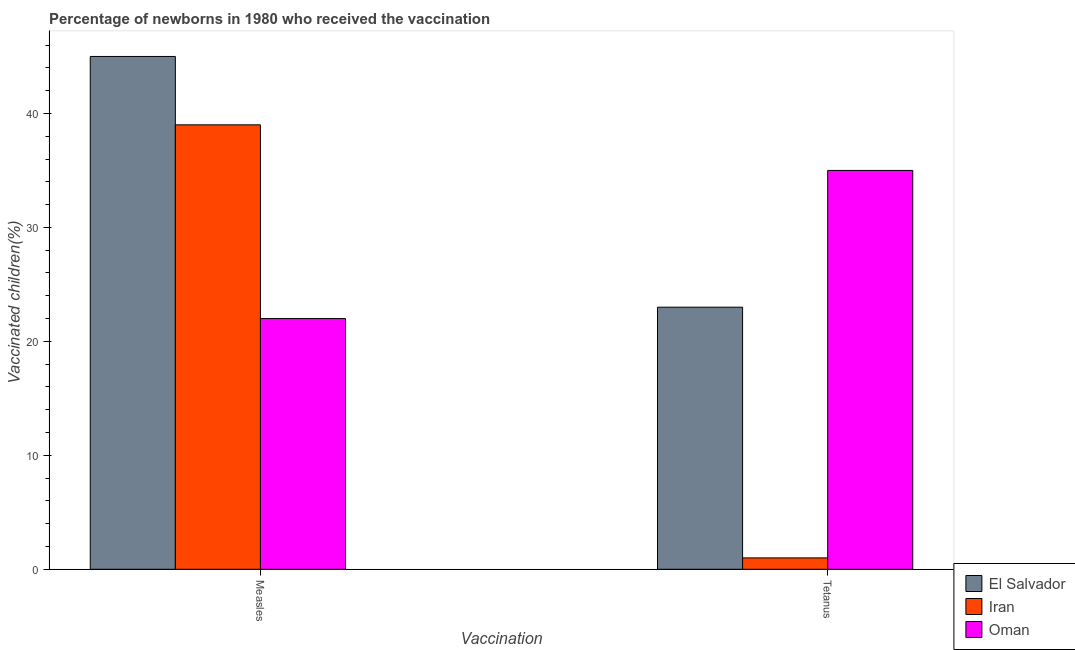How many different coloured bars are there?
Offer a very short reply. 3. How many groups of bars are there?
Your answer should be compact. 2. Are the number of bars per tick equal to the number of legend labels?
Keep it short and to the point. Yes. Are the number of bars on each tick of the X-axis equal?
Your answer should be compact. Yes. How many bars are there on the 2nd tick from the right?
Your answer should be compact. 3. What is the label of the 2nd group of bars from the left?
Provide a short and direct response. Tetanus. What is the percentage of newborns who received vaccination for measles in El Salvador?
Ensure brevity in your answer.  45. Across all countries, what is the maximum percentage of newborns who received vaccination for measles?
Make the answer very short. 45. Across all countries, what is the minimum percentage of newborns who received vaccination for measles?
Provide a succinct answer. 22. In which country was the percentage of newborns who received vaccination for measles maximum?
Your response must be concise. El Salvador. In which country was the percentage of newborns who received vaccination for tetanus minimum?
Keep it short and to the point. Iran. What is the total percentage of newborns who received vaccination for measles in the graph?
Give a very brief answer. 106. What is the difference between the percentage of newborns who received vaccination for tetanus in Iran and that in Oman?
Offer a terse response. -34. What is the difference between the percentage of newborns who received vaccination for measles in El Salvador and the percentage of newborns who received vaccination for tetanus in Iran?
Offer a very short reply. 44. What is the average percentage of newborns who received vaccination for measles per country?
Offer a terse response. 35.33. What is the difference between the percentage of newborns who received vaccination for measles and percentage of newborns who received vaccination for tetanus in Iran?
Make the answer very short. 38. In how many countries, is the percentage of newborns who received vaccination for tetanus greater than 42 %?
Provide a short and direct response. 0. What is the ratio of the percentage of newborns who received vaccination for measles in Iran to that in Oman?
Offer a terse response. 1.77. Is the percentage of newborns who received vaccination for tetanus in El Salvador less than that in Oman?
Your answer should be very brief. Yes. What does the 3rd bar from the left in Tetanus represents?
Ensure brevity in your answer.  Oman. What does the 1st bar from the right in Tetanus represents?
Ensure brevity in your answer.  Oman. How many countries are there in the graph?
Offer a terse response. 3. What is the difference between two consecutive major ticks on the Y-axis?
Your answer should be very brief. 10. Are the values on the major ticks of Y-axis written in scientific E-notation?
Ensure brevity in your answer.  No. Where does the legend appear in the graph?
Make the answer very short. Bottom right. What is the title of the graph?
Keep it short and to the point. Percentage of newborns in 1980 who received the vaccination. What is the label or title of the X-axis?
Make the answer very short. Vaccination. What is the label or title of the Y-axis?
Provide a short and direct response. Vaccinated children(%)
. What is the Vaccinated children(%)
 in Iran in Measles?
Your response must be concise. 39. What is the Vaccinated children(%)
 in Oman in Tetanus?
Your response must be concise. 35. Across all Vaccination, what is the maximum Vaccinated children(%)
 of El Salvador?
Your response must be concise. 45. Across all Vaccination, what is the maximum Vaccinated children(%)
 of Iran?
Offer a very short reply. 39. Across all Vaccination, what is the maximum Vaccinated children(%)
 of Oman?
Ensure brevity in your answer.  35. Across all Vaccination, what is the minimum Vaccinated children(%)
 of El Salvador?
Offer a very short reply. 23. Across all Vaccination, what is the minimum Vaccinated children(%)
 of Iran?
Your answer should be very brief. 1. Across all Vaccination, what is the minimum Vaccinated children(%)
 of Oman?
Your answer should be compact. 22. What is the total Vaccinated children(%)
 of Oman in the graph?
Offer a terse response. 57. What is the difference between the Vaccinated children(%)
 of El Salvador in Measles and that in Tetanus?
Provide a succinct answer. 22. What is the difference between the Vaccinated children(%)
 of Iran in Measles and that in Tetanus?
Your response must be concise. 38. What is the difference between the Vaccinated children(%)
 of Oman in Measles and that in Tetanus?
Offer a very short reply. -13. What is the difference between the Vaccinated children(%)
 of El Salvador in Measles and the Vaccinated children(%)
 of Iran in Tetanus?
Keep it short and to the point. 44. What is the difference between the Vaccinated children(%)
 of El Salvador in Measles and the Vaccinated children(%)
 of Oman in Tetanus?
Provide a short and direct response. 10. What is the average Vaccinated children(%)
 of El Salvador per Vaccination?
Give a very brief answer. 34. What is the average Vaccinated children(%)
 in Iran per Vaccination?
Provide a succinct answer. 20. What is the difference between the Vaccinated children(%)
 of El Salvador and Vaccinated children(%)
 of Oman in Measles?
Offer a very short reply. 23. What is the difference between the Vaccinated children(%)
 of El Salvador and Vaccinated children(%)
 of Iran in Tetanus?
Offer a very short reply. 22. What is the difference between the Vaccinated children(%)
 of Iran and Vaccinated children(%)
 of Oman in Tetanus?
Give a very brief answer. -34. What is the ratio of the Vaccinated children(%)
 of El Salvador in Measles to that in Tetanus?
Your response must be concise. 1.96. What is the ratio of the Vaccinated children(%)
 of Oman in Measles to that in Tetanus?
Provide a succinct answer. 0.63. What is the difference between the highest and the second highest Vaccinated children(%)
 in El Salvador?
Give a very brief answer. 22. What is the difference between the highest and the second highest Vaccinated children(%)
 of Iran?
Offer a very short reply. 38. What is the difference between the highest and the second highest Vaccinated children(%)
 in Oman?
Your response must be concise. 13. What is the difference between the highest and the lowest Vaccinated children(%)
 of Iran?
Your answer should be very brief. 38. 